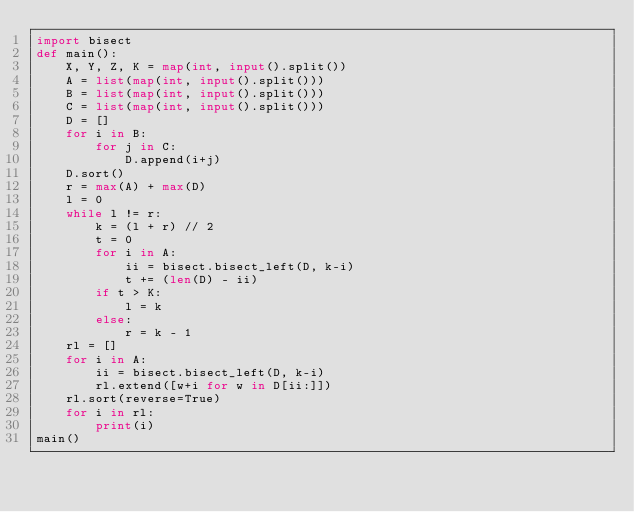<code> <loc_0><loc_0><loc_500><loc_500><_Python_>import bisect
def main():
    X, Y, Z, K = map(int, input().split())
    A = list(map(int, input().split()))
    B = list(map(int, input().split()))
    C = list(map(int, input().split()))
    D = []
    for i in B:
        for j in C:
            D.append(i+j)
    D.sort()
    r = max(A) + max(D)
    l = 0
    while l != r:
        k = (l + r) // 2
        t = 0
        for i in A:
            ii = bisect.bisect_left(D, k-i)
            t += (len(D) - ii)
        if t > K:
            l = k
        else:
            r = k - 1
    rl = []
    for i in A:
        ii = bisect.bisect_left(D, k-i)
        rl.extend([w+i for w in D[ii:]])
    rl.sort(reverse=True)
    for i in rl:
        print(i)
main()
</code> 